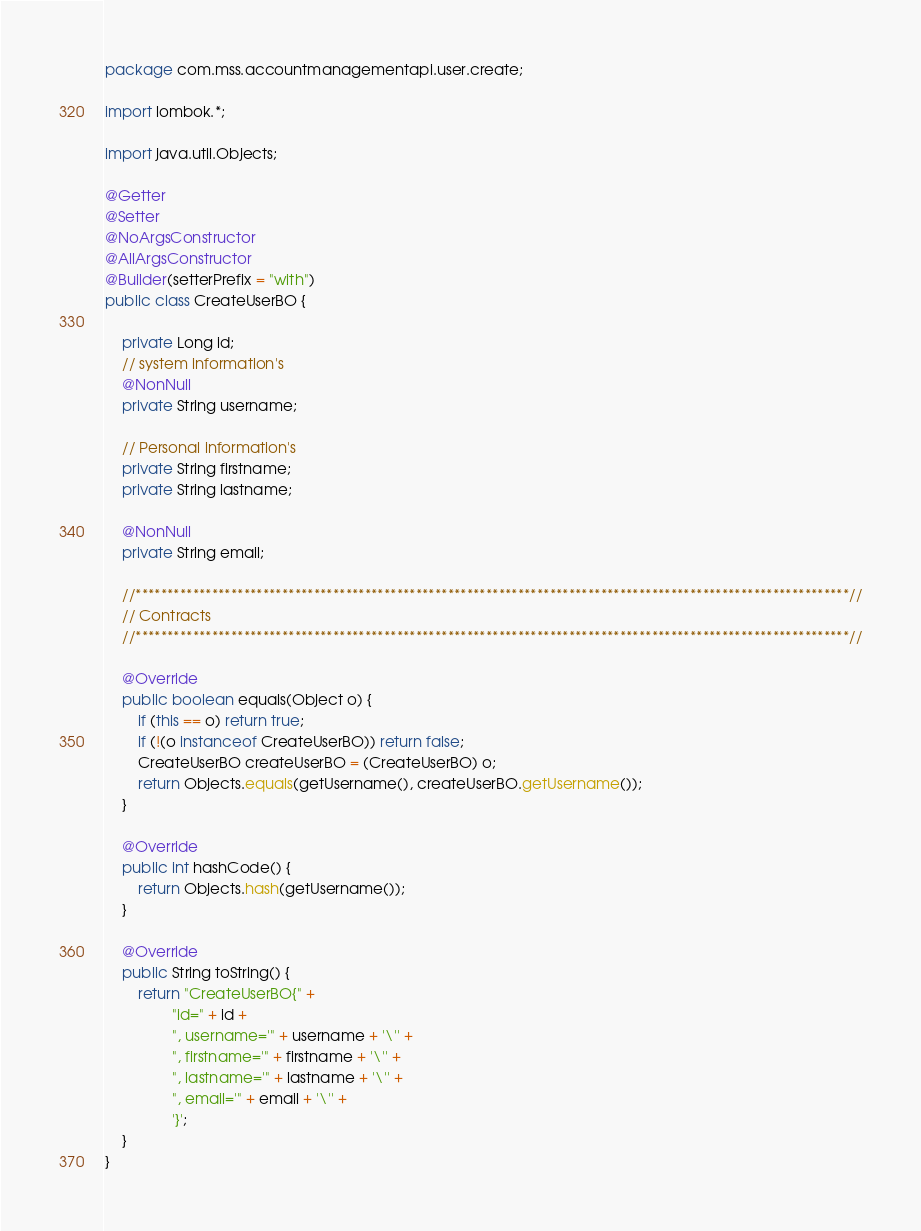Convert code to text. <code><loc_0><loc_0><loc_500><loc_500><_Java_>package com.mss.accountmanagementapi.user.create;

import lombok.*;

import java.util.Objects;

@Getter
@Setter
@NoArgsConstructor
@AllArgsConstructor
@Builder(setterPrefix = "with")
public class CreateUserBO {

    private Long id;
    // system information's
    @NonNull
    private String username;

    // Personal information's
    private String firstname;
    private String lastname;

    @NonNull
    private String email;

    //****************************************************************************************************************//
    // Contracts
    //****************************************************************************************************************//

    @Override
    public boolean equals(Object o) {
        if (this == o) return true;
        if (!(o instanceof CreateUserBO)) return false;
        CreateUserBO createUserBO = (CreateUserBO) o;
        return Objects.equals(getUsername(), createUserBO.getUsername());
    }

    @Override
    public int hashCode() {
        return Objects.hash(getUsername());
    }

    @Override
    public String toString() {
        return "CreateUserBO{" +
                "id=" + id +
                ", username='" + username + '\'' +
                ", firstname='" + firstname + '\'' +
                ", lastname='" + lastname + '\'' +
                ", email='" + email + '\'' +
                '}';
    }
}
</code> 